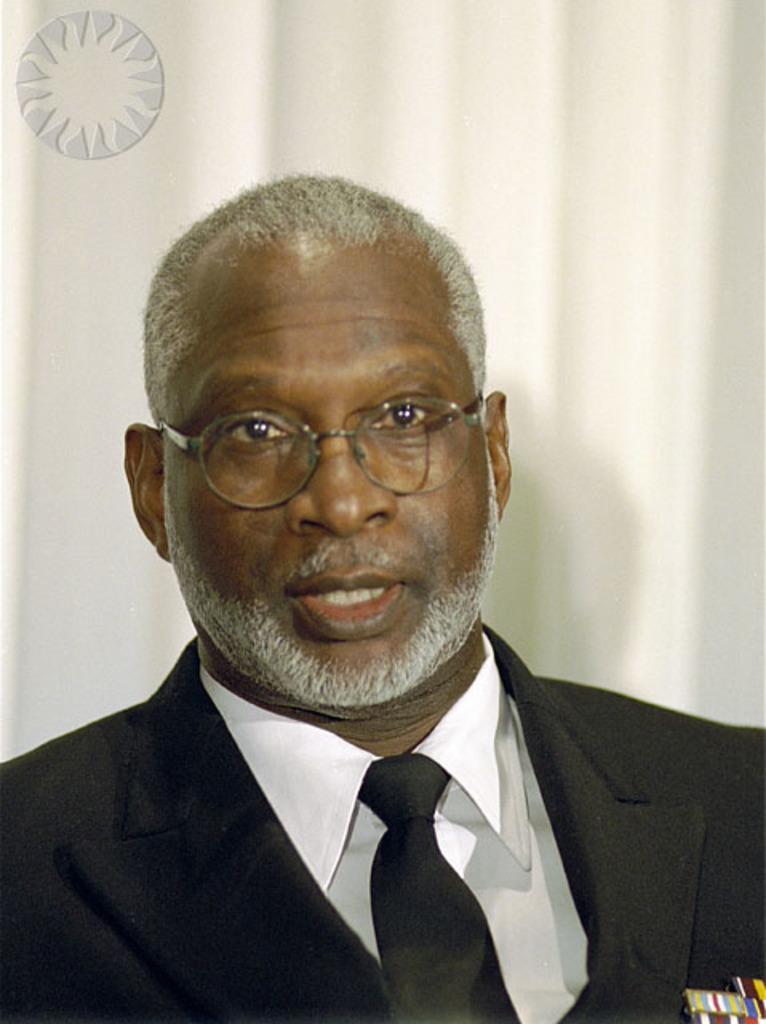Please provide a concise description of this image. In this image, we can see a person on the white background. This person is wearing clothes and spectacles. There is logo in the top left of the image. 